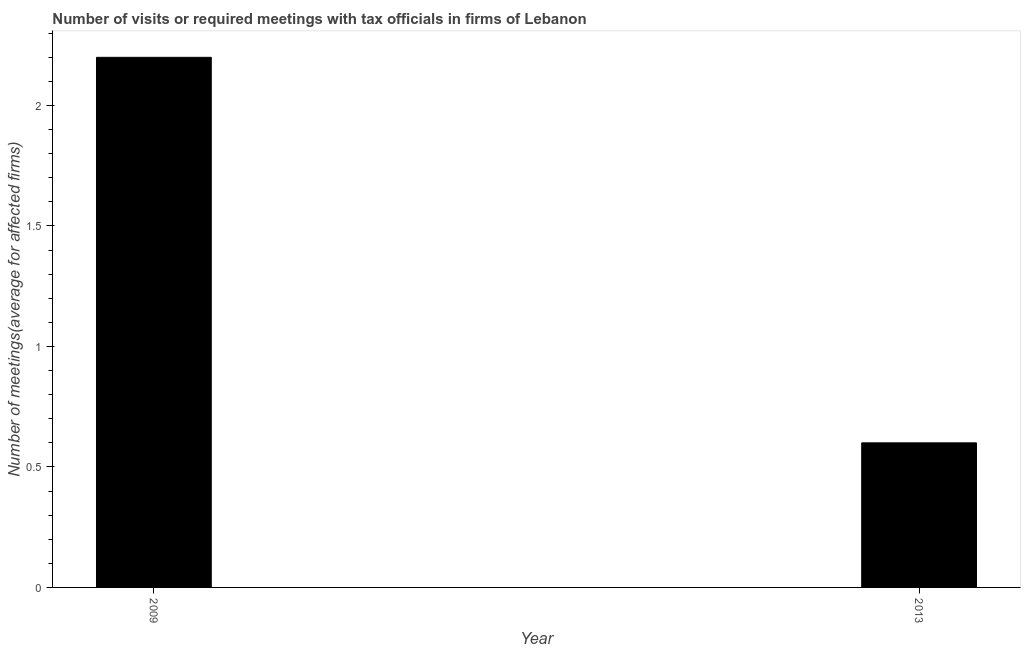Does the graph contain grids?
Provide a succinct answer. No. What is the title of the graph?
Keep it short and to the point. Number of visits or required meetings with tax officials in firms of Lebanon. What is the label or title of the X-axis?
Offer a very short reply. Year. What is the label or title of the Y-axis?
Ensure brevity in your answer.  Number of meetings(average for affected firms). Across all years, what is the minimum number of required meetings with tax officials?
Make the answer very short. 0.6. In which year was the number of required meetings with tax officials maximum?
Offer a terse response. 2009. In which year was the number of required meetings with tax officials minimum?
Your response must be concise. 2013. What is the sum of the number of required meetings with tax officials?
Your answer should be compact. 2.8. What is the average number of required meetings with tax officials per year?
Make the answer very short. 1.4. What is the median number of required meetings with tax officials?
Your answer should be compact. 1.4. Do a majority of the years between 2009 and 2013 (inclusive) have number of required meetings with tax officials greater than 1.6 ?
Provide a succinct answer. No. What is the ratio of the number of required meetings with tax officials in 2009 to that in 2013?
Give a very brief answer. 3.67. How many bars are there?
Offer a very short reply. 2. Are all the bars in the graph horizontal?
Your response must be concise. No. How many years are there in the graph?
Offer a very short reply. 2. What is the difference between two consecutive major ticks on the Y-axis?
Your answer should be compact. 0.5. Are the values on the major ticks of Y-axis written in scientific E-notation?
Offer a terse response. No. What is the Number of meetings(average for affected firms) of 2009?
Your answer should be very brief. 2.2. What is the ratio of the Number of meetings(average for affected firms) in 2009 to that in 2013?
Your answer should be compact. 3.67. 